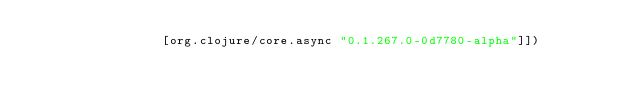Convert code to text. <code><loc_0><loc_0><loc_500><loc_500><_Clojure_>                 [org.clojure/core.async "0.1.267.0-0d7780-alpha"]])
</code> 